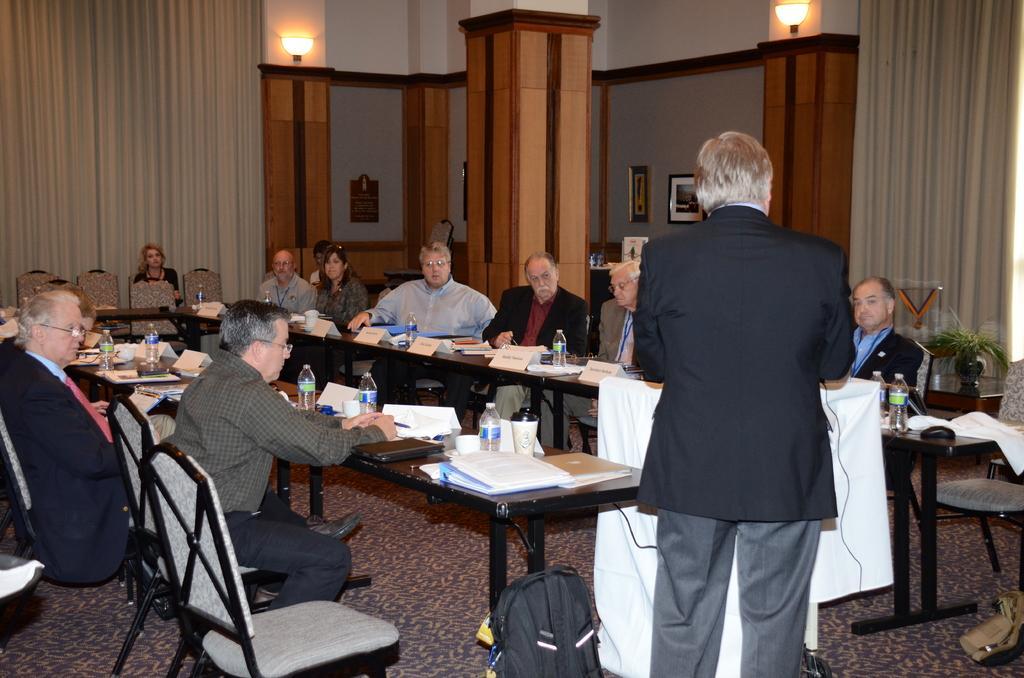Please provide a concise description of this image. Here we can see some persons are sitting on the chairs. This is table. On the table there are bottles, and books. There is a bag. Here we can see a person who is standing on the floor. And this is carpet. On the background there is a wall and this is pillar. These are the lights and there is a curtain. Here we can see frames on the wall. 